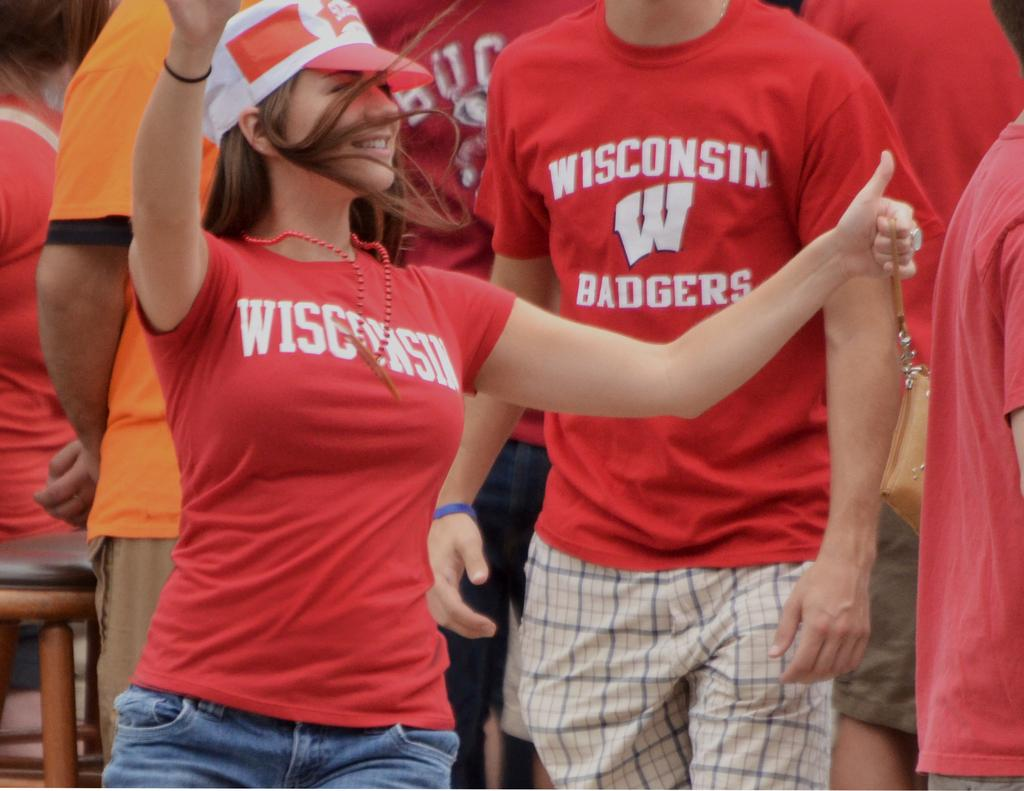How many people are in the image? There is a group of people in the image. Can you describe the clothing of the woman in the front? The woman in the front is wearing a cap, a red color T-shirt, and jeans. What can be seen in the background of the image? There are objects in the background of the image. Can you hear the tiger coughing in the image? There is no tiger or any sound mentioned in the image, so it is not possible to answer that question. 